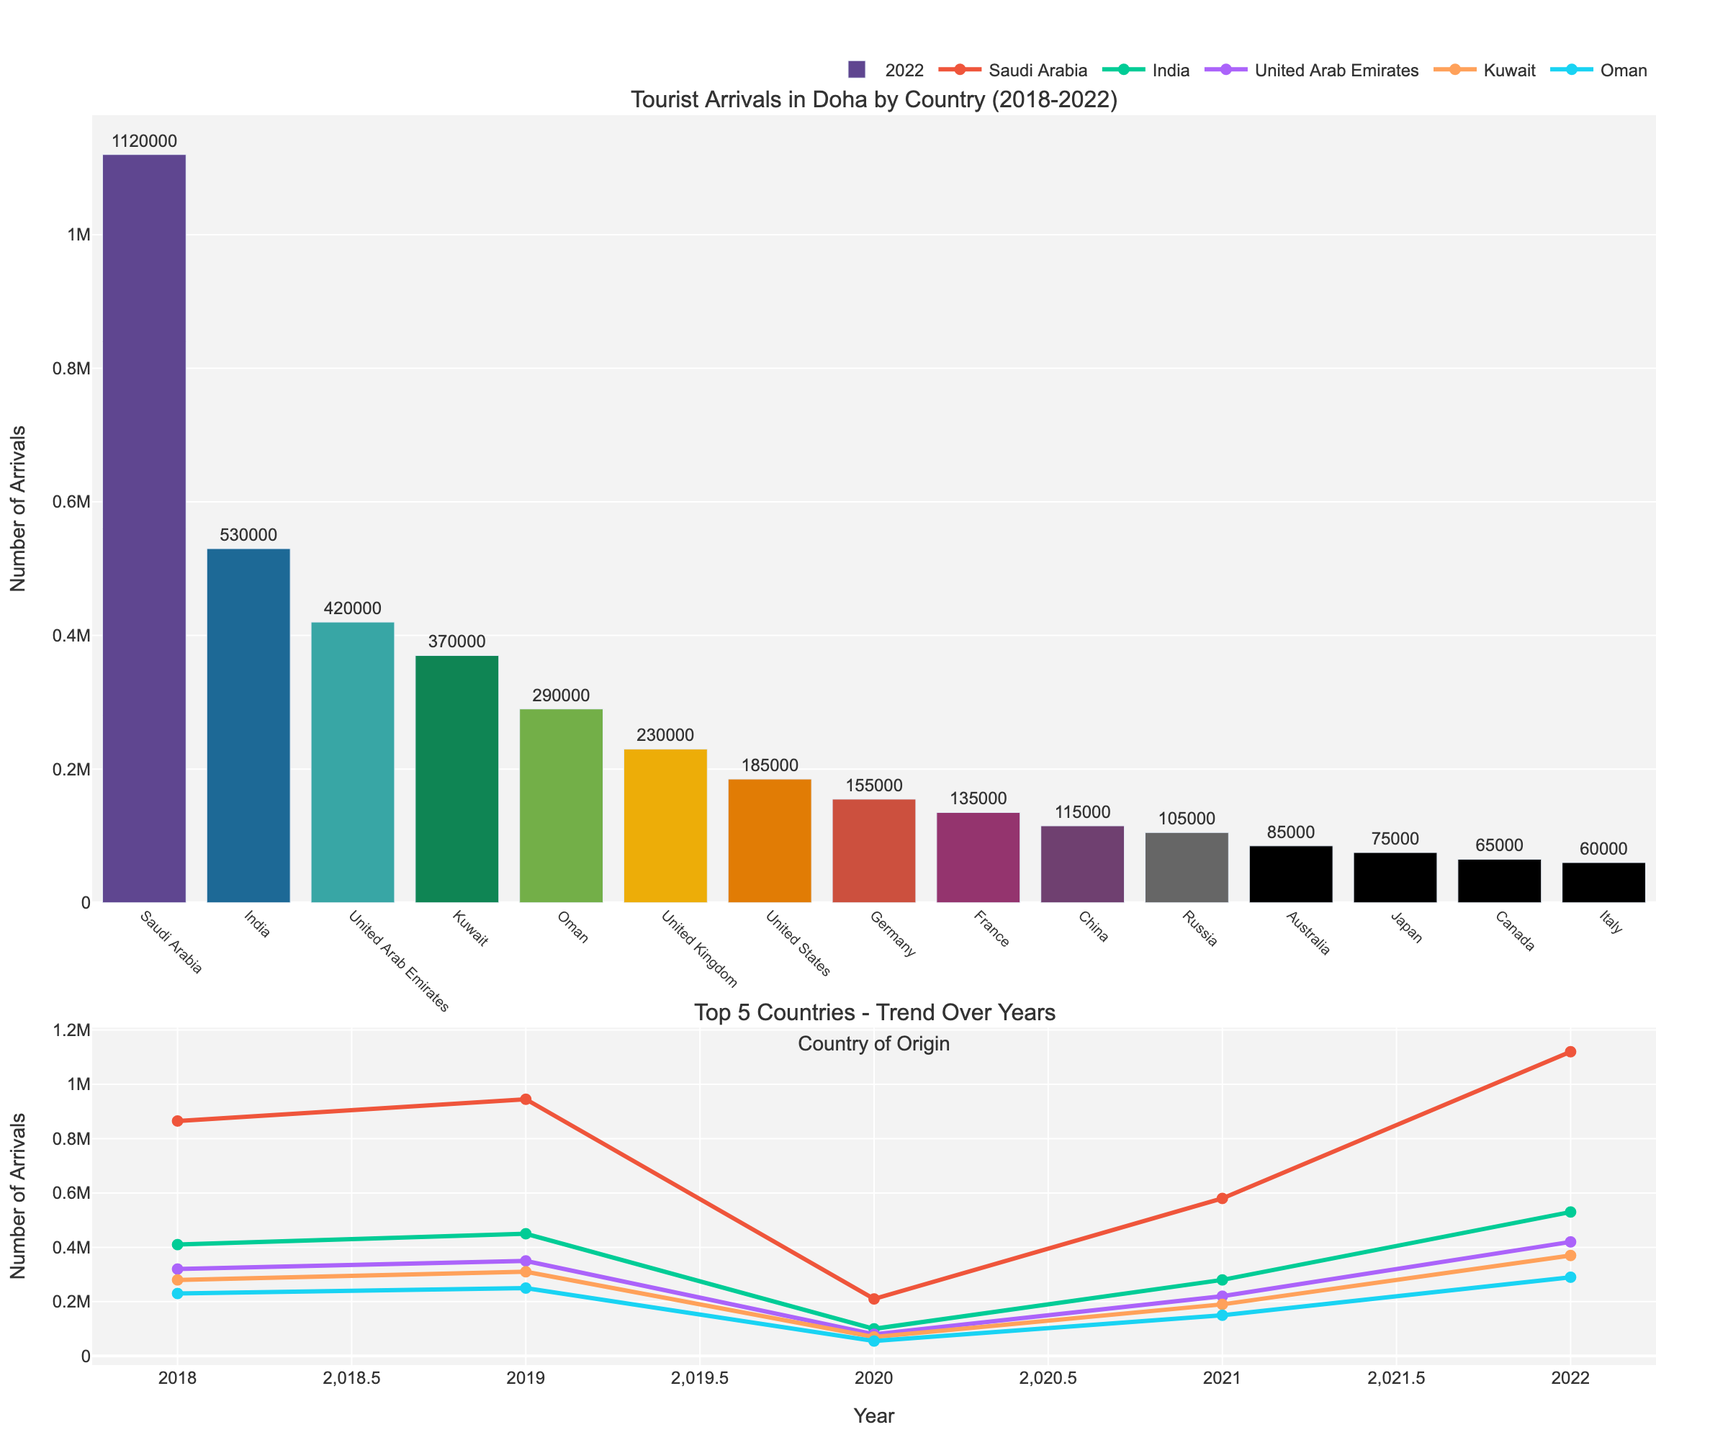Which country had the highest number of tourist arrivals in Doha in 2022? By visually inspecting the bar chart for 2022, the bar for Saudi Arabia is the highest among all, indicating it had the most tourist arrivals.
Answer: Saudi Arabia How did the number of tourist arrivals from the United States change from 2018 to 2022? Observing the line chart for the United States, the arrivals increased from 150,000 in 2018 to 165,000 in 2019, then dropped to 35,000 in 2020, and gradually increased again to 95,000 in 2021 and to 185,000 in 2022.
Answer: Increased, then decreased, then increased Which country had the smallest growth in tourist arrivals from 2018 to 2022? By comparing the Data 2022 and looking at the line charts, the tourist arrivals from Japan grew from 60,000 in 2018 to 75,000 in 2022, which is the smallest growth compared to other countries.
Answer: Japan What is the total number of tourist arrivals from the top 5 countries combined in 2022? The top 5 countries are Saudi Arabia, United Arab Emirates, Kuwait, Oman, and India. Adding their tourist arrivals for 2022: 1,120,000 (Saudi Arabia) + 420,000 (UAE) + 370,000 (Kuwait) + 290,000 (Oman) + 530,000 (India) = 2,730,000.
Answer: 2,730,000 Which country experienced the greatest drop in tourist arrivals in 2020 compared to 2019? By checking the data for various countries, the United Arab Emirates dropped from 350,000 in 2019 to 80,000 in 2020. Calculating the drop: 350,000 - 80,000 = 270,000, which is the greatest among the given countries.
Answer: United Arab Emirates What is the average number of tourist arrivals from Germany over the 5 years? Summing up the arrivals from 2018 to 2022 for Germany: 120,000 + 130,000 + 30,000 + 80,000 + 155,000 = 515,000. The average is then 515,000 / 5 = 103,000.
Answer: 103,000 How did the tourist arrivals trend for India vary over the 5 years? Checking India's line chart, the tourists increased from 410,000 in 2018 to 450,000 in 2019, dropped to 100,000 in 2020, then rose to 280,000 in 2021 and reached 530,000 in 2022.
Answer: Increased, then decreased, then increased What is the difference in tourist arrivals between France and China in 2022? Subtract China's arrivals from France's arrivals in 2022: 135,000 (France) - 115,000 (China) = 20,000.
Answer: 20,000 Which country had more tourist arrivals in 2022, Russia or Germany? By looking at the bar chart for 2022, Germany had around 155,000 and Russia had 105,000. Hence, Germany had more arrivals.
Answer: Germany Of the top 5 countries in 2022, which country showed a consistent increase in tourist arrivals every year from 2018 to 2022? By looking at the line charts, Saudi Arabia shows a consistent increase in tourist arrivals every year from 2018 to 2022.
Answer: Saudi Arabia 